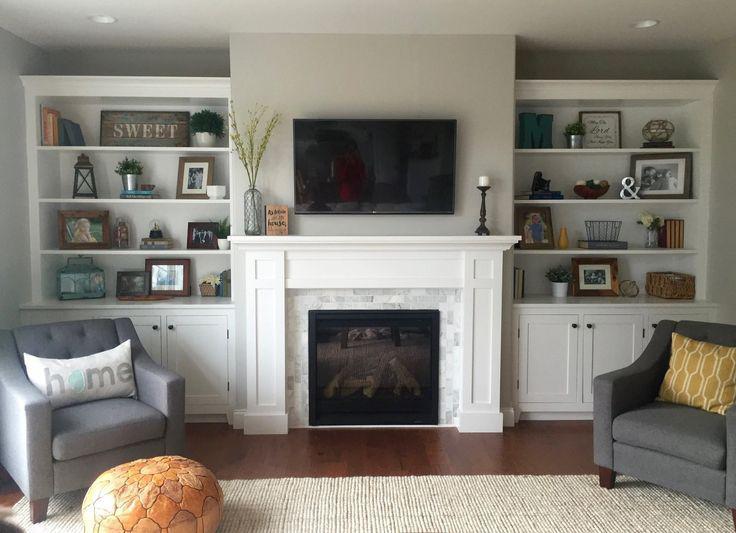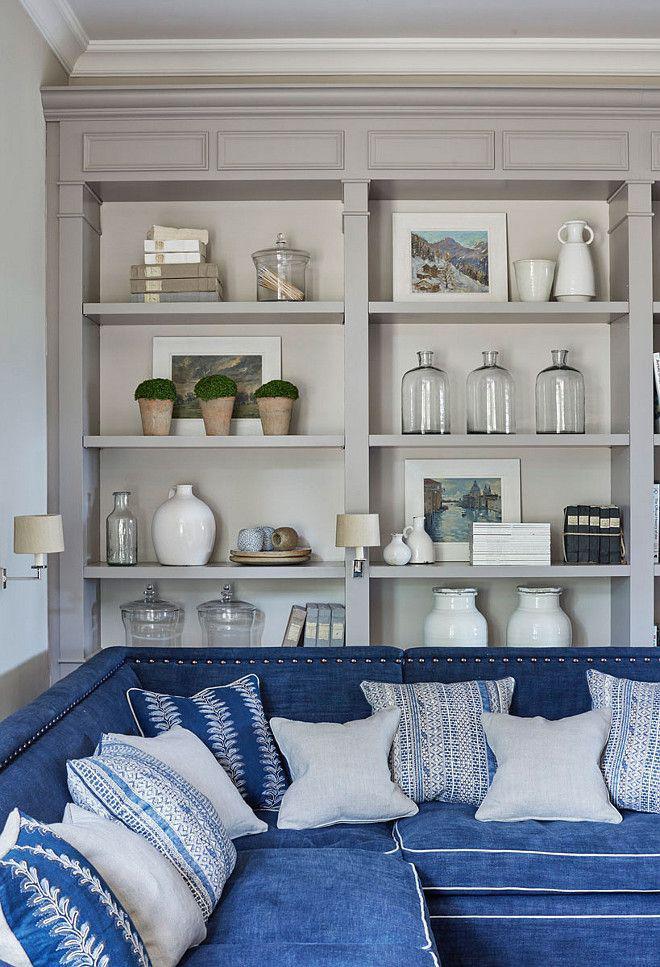The first image is the image on the left, the second image is the image on the right. Evaluate the accuracy of this statement regarding the images: "A television hangs over the mantle in the image on the left.". Is it true? Answer yes or no. Yes. 